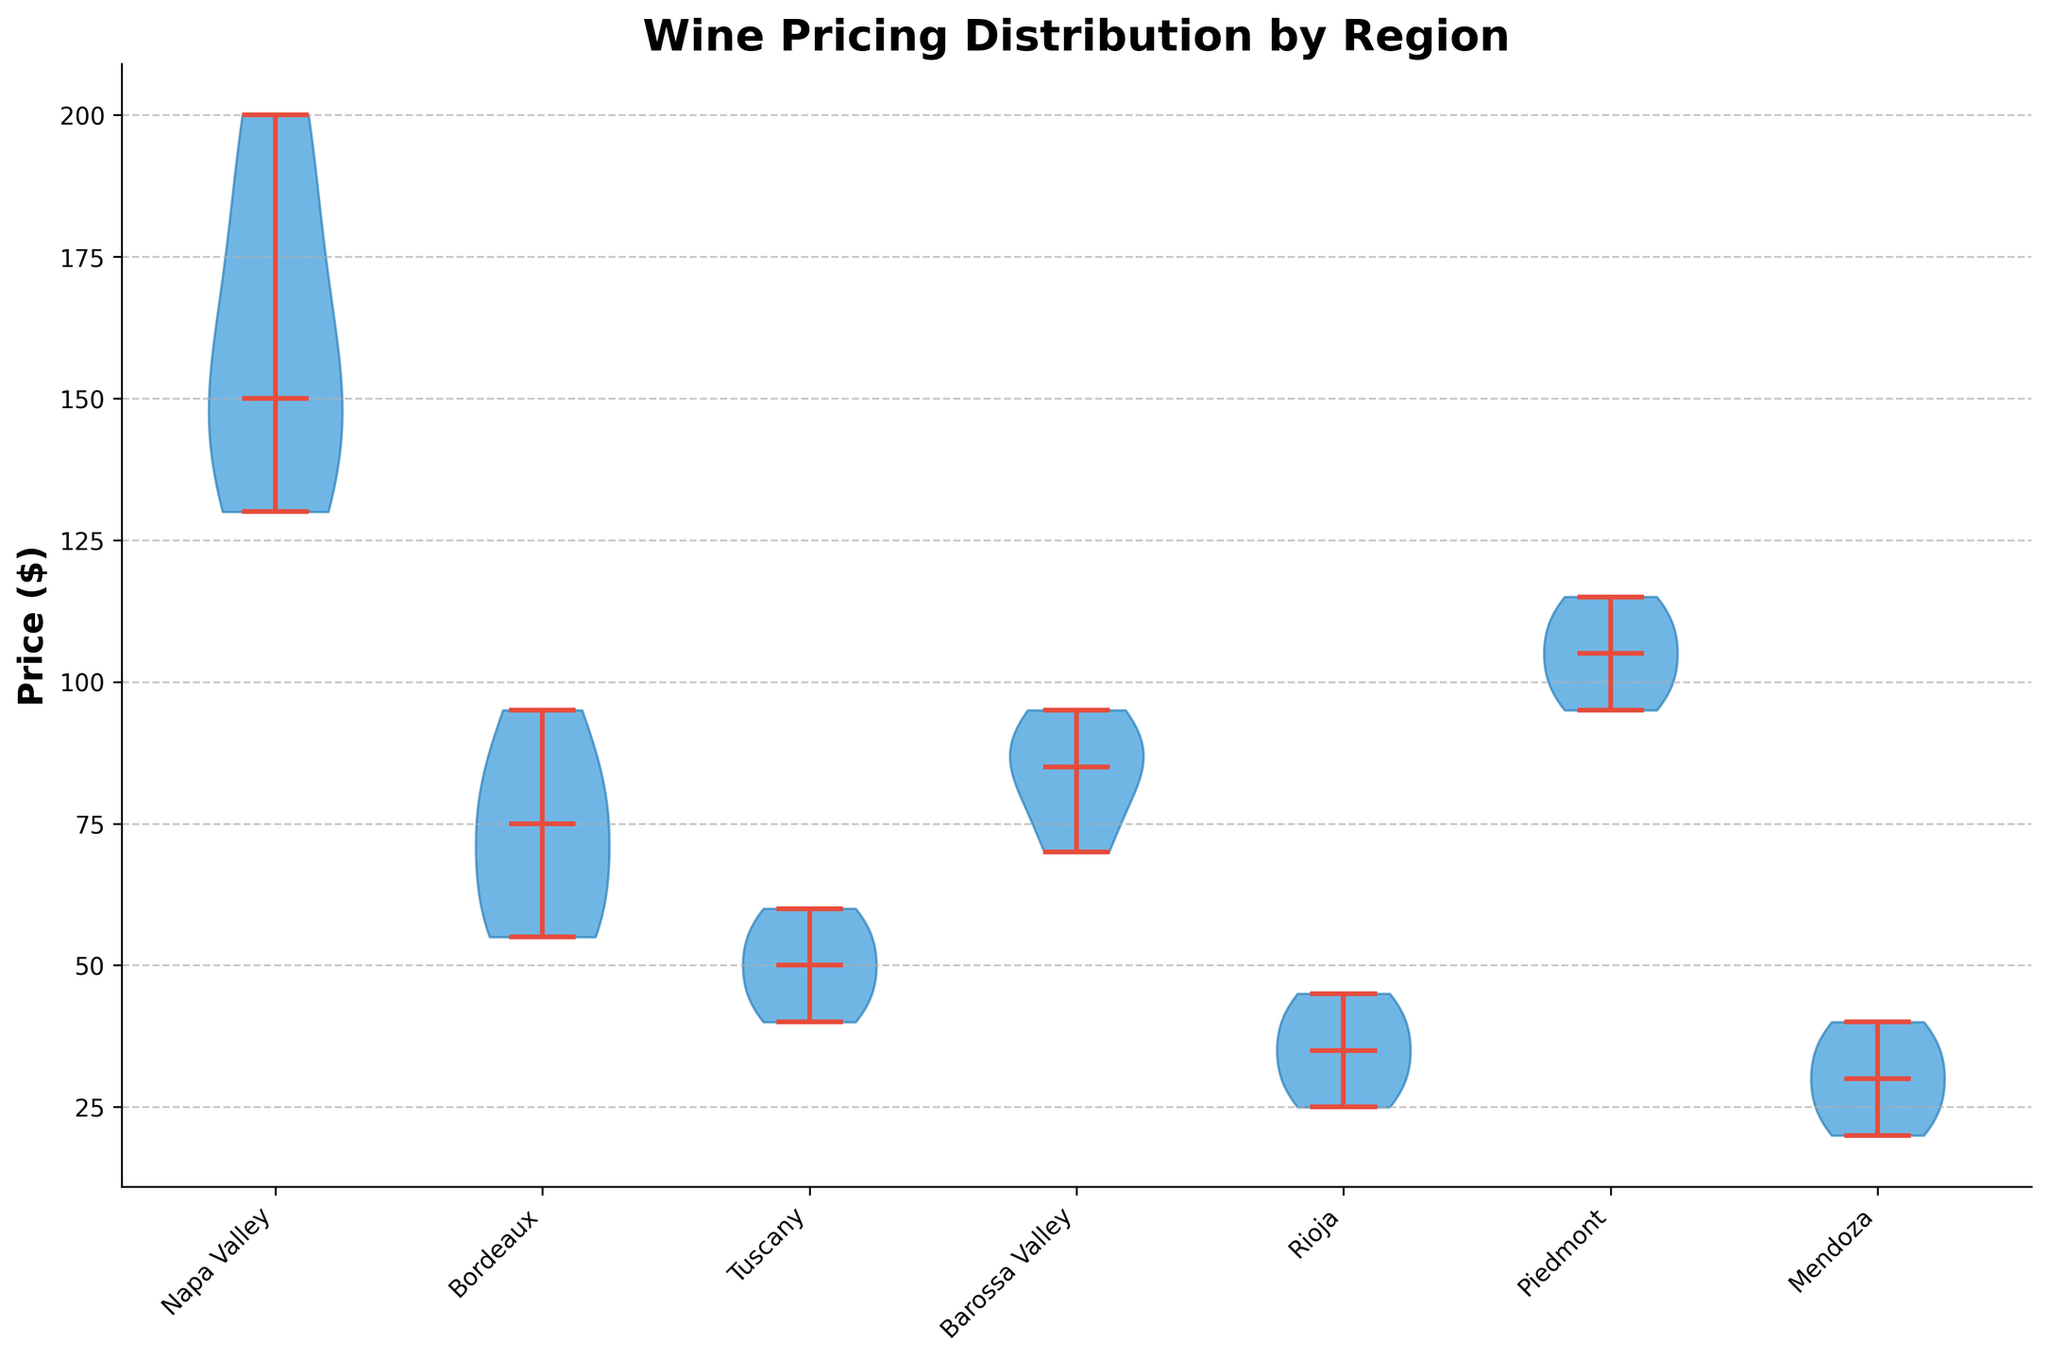What is the range of wine prices in Napa Valley? From the figure, we can see the vertical spread of the violin for Napa Valley, which extends from the minimum to the maximum price point. The prices range from approximately $130 to $200.
Answer: $130 to $200 Which region has the lowest median wine price? To find the lowest median price, we need to compare the central line within the violins (indicating the median) across all regions. Rioja’s median line appears lowest.
Answer: Rioja How does the price variability in Bordeaux compare to Mendoza? Bordeaux’s violin is much wider and shows more variation, whereas Mendoza’s is narrower, indicating less price variability.
Answer: Bordeaux has greater variability What is the general price trend in Tuscany? Tuscany’s violin is relatively narrow and centered around lower prices, with the majority of prices between $40 and $60. This indicates a concentration in a lower price range.
Answer: Concentrated in a lower price range Which regions show significant price outliers? Examining the violins, it’s clear that Napa Valley and Piedmont have more pronounced tails indicating outliers, with some prices significantly higher than the rest.
Answer: Napa Valley and Piedmont Are there any regions with overlapping price distributions? The violins for Bordeaux and Barossa Valley overlap somewhat in their range, indicating similar price distributions between these regions.
Answer: Bordeaux and Barossa Valley Which region has the highest maximum wine price? The topmost point of the Napa Valley violin reaches the highest on the price axis, indicating the highest maximum price around $200.
Answer: Napa Valley What is the interquartile range (IQR) for Piedmont wines? The IQR can be estimated by visually identifying the widest part of the violin for Piedmont, which appears to be between $95 and $110.
Answer: $95 to $110 How do the price medians of Napa Valley and Mendoza differ? The median line for Napa Valley is much higher than that of Mendoza, indicating that the median price of Napa Valley wines is significantly higher.
Answer: Napa Valley is higher Which region’s wines exhibit the narrowest price range? Rioja’s violin chart is the narrowest among all, indicating the most constrained price range, which is approximately between $25 and $45.
Answer: Rioja 